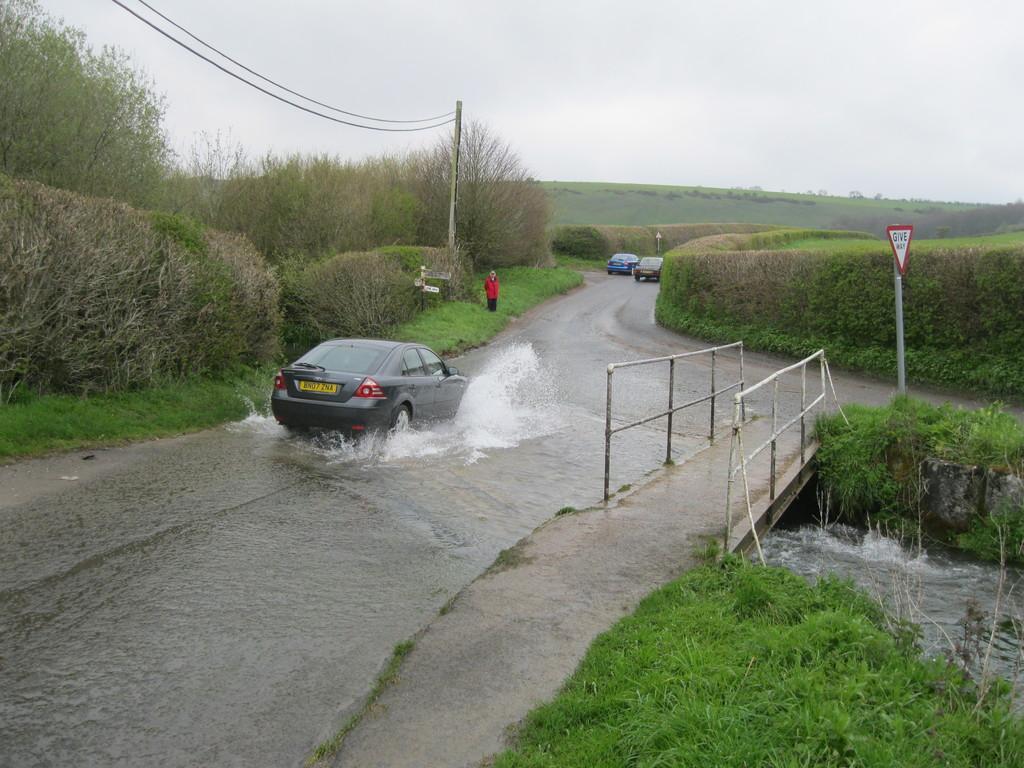In one or two sentences, can you explain what this image depicts? In this image there are few vehicles are moving on the road and there is a water on the road. On the left side of the image there are trees and there is a person standing on the grass, on the other side of the image there are some metal structures, grass, trees, in the middle of the grass there is a water flow. In the background there is the sky. 